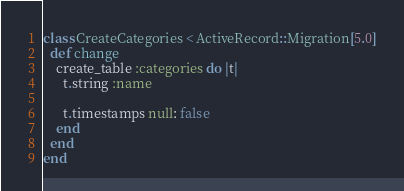<code> <loc_0><loc_0><loc_500><loc_500><_Ruby_>class CreateCategories < ActiveRecord::Migration[5.0]
  def change
    create_table :categories do |t|
      t.string :name

      t.timestamps null: false
    end
  end
end
</code> 